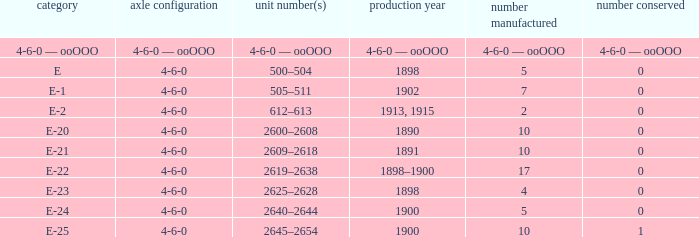What is the fleet number with a 4-6-0 wheel arrangement made in 1890? 2600–2608. 